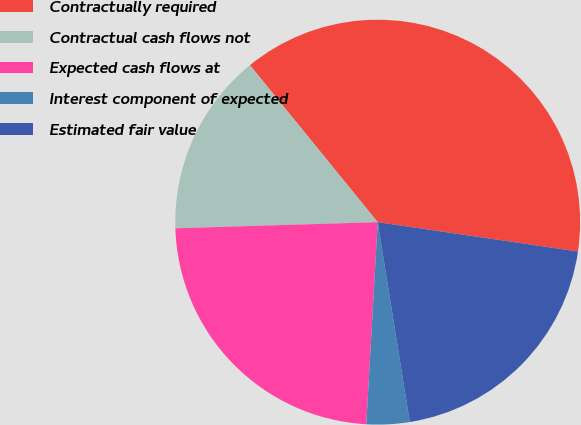<chart> <loc_0><loc_0><loc_500><loc_500><pie_chart><fcel>Contractually required<fcel>Contractual cash flows not<fcel>Expected cash flows at<fcel>Interest component of expected<fcel>Estimated fair value<nl><fcel>38.19%<fcel>14.61%<fcel>23.62%<fcel>3.43%<fcel>20.15%<nl></chart> 